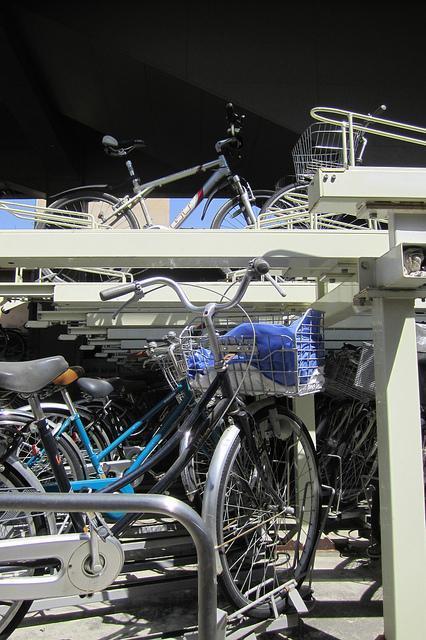How many bicycles can you see?
Give a very brief answer. 5. How many bananas are in the picture?
Give a very brief answer. 0. 